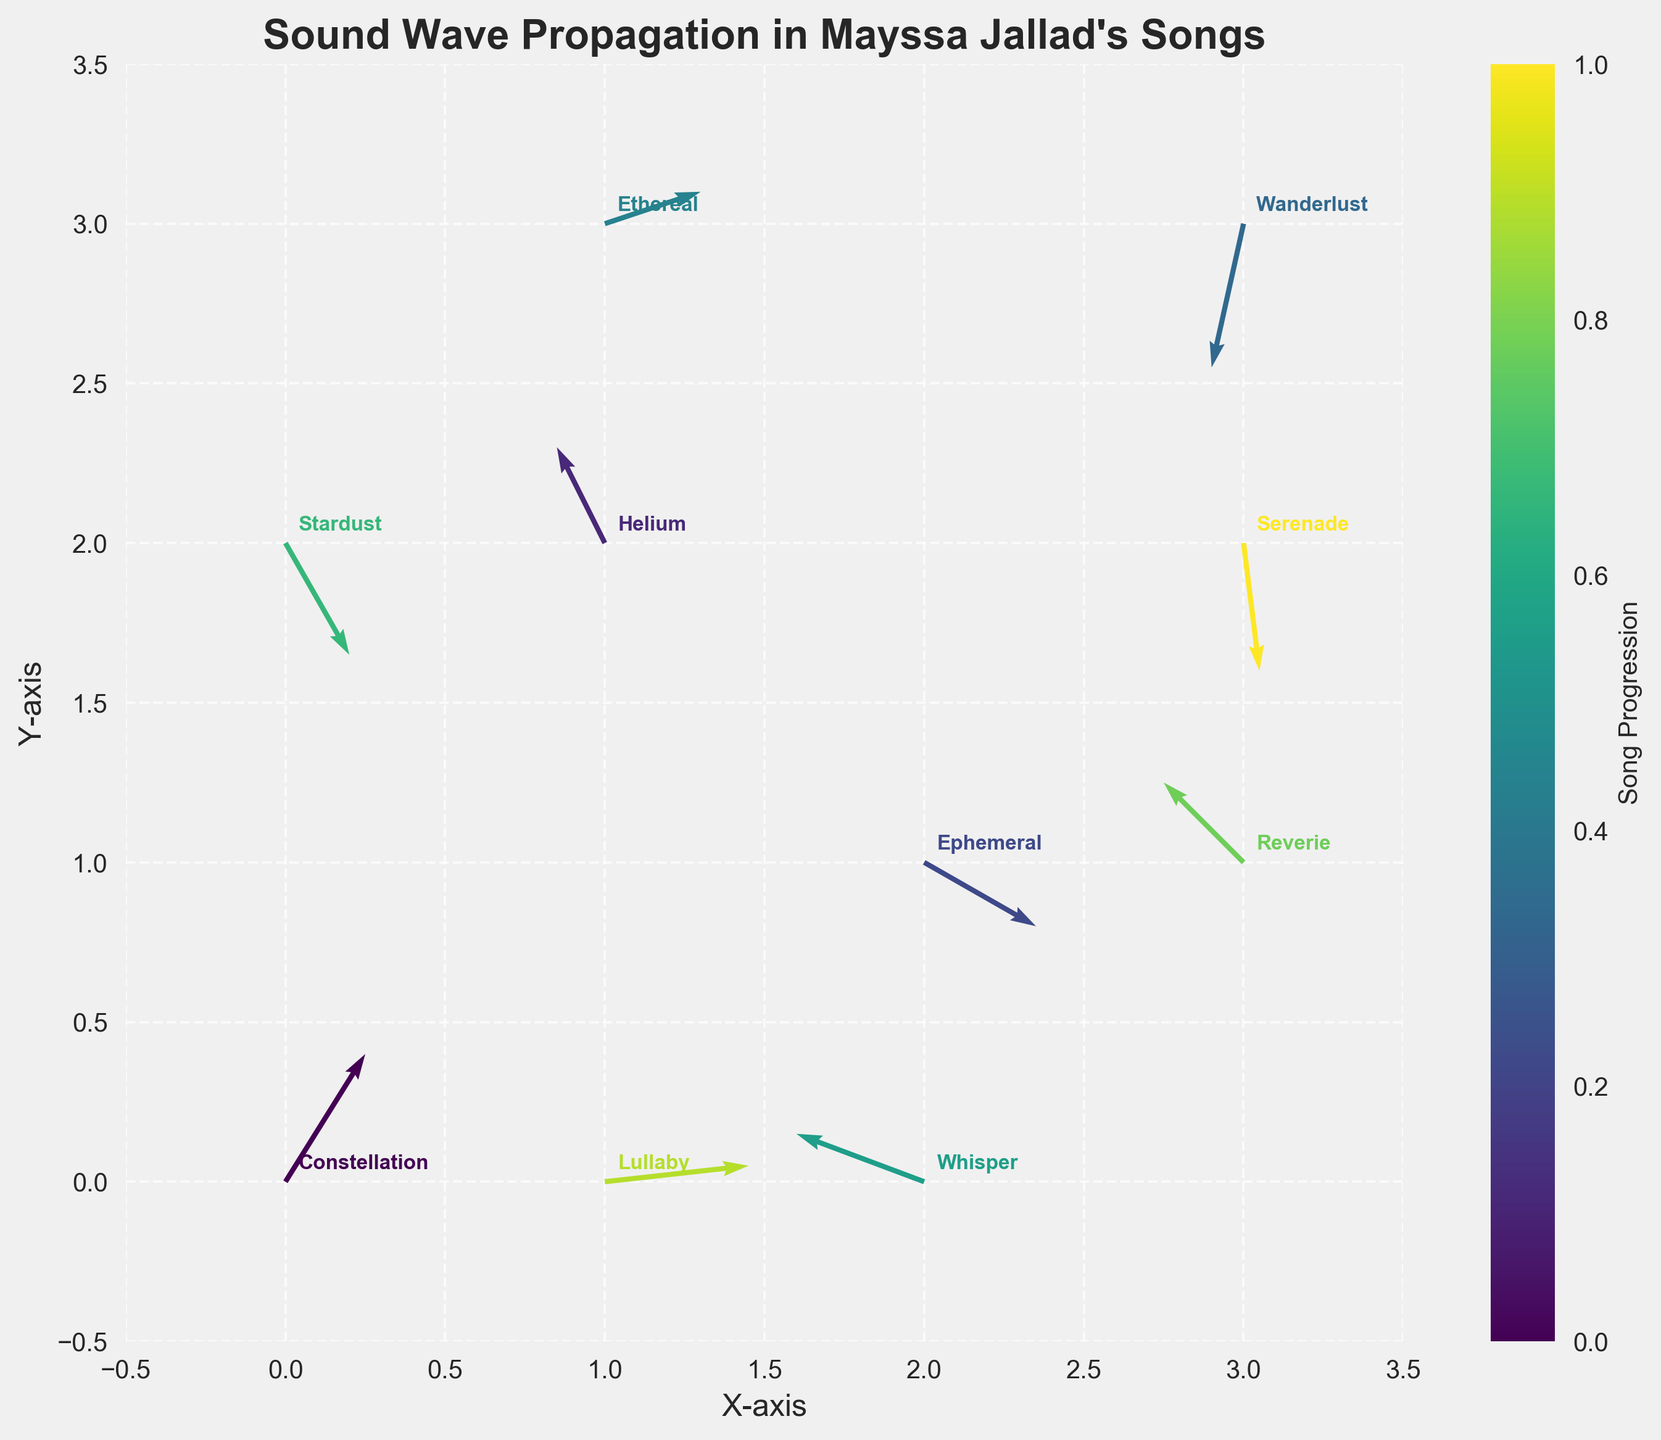What is the title of the figure? The title of the figure is typically displayed at the top center part of the plot. In this case, it reads "Sound Wave Propagation in Mayssa Jallad's Songs".
Answer: Sound Wave Propagation in Mayssa Jallad's Songs How many songs are represented in the figure? The figure has one quiver arrow and one annotation for each unique song. By counting the annotations or arrows, we find that there are 10 songs represented.
Answer: 10 Which song corresponds to the quiver located at coordinate (3, 2)? The song annotations near the coordinates can help us identify it. The annotation closest to (3, 2) is "Serenade".
Answer: Serenade What is the direction of the quiver associated with the song "Lullaby"? The quiver corresponding to "Lullaby" starts from coordinate (1, 0) and has direction components u=0.9 and v=0.1. This means it points roughly to the right and slightly upwards.
Answer: Right and slightly upwards Which song has the largest magnitude vector? To find this, look for the highest value in the magnitude data. The song with the largest magnitude (0.94) is "Constellation".
Answer: Constellation What is the general trend of the quiver vectors' directions? By observing the orientations of the quiver arrows, many vectors seem to have positive or negative values of both x and y components, showing diversity and complexity in directions.
Answer: Diverse directions with no singular trend What is the average magnitude of the vectors in the plot? The magnitudes listed are 0.94, 0.67, 0.81, 0.92, 0.63, 0.85, 0.81, 0.71, 0.91, and 0.81. Summing these gives 7.06, and dividing by the number of songs (10) gives us 0.706.
Answer: 0.706 Which song’s quiver has the largest positive x-component (u)? The song with the largest positive x-component (u) can be identified by checking individual u values. "Lullaby" has u=0.9, which is the highest.
Answer: Lullaby Which two songs’ quivers point in almost completely opposite directions? By comparing the directions of the u and v components, we can infer that "Constellation" (u=0.5, v=0.8) and "Wanderlust" (u=-0.2, v=-0.9) point in nearly opposite directions.
Answer: Constellation and Wanderlust Which song has quiver vectors closest to the origin with a downward direction? Quivers closest to the origin that point downward would have negative y-components. Observing this, "Ephemeral" at (2,1) has u=0.7 and v=-0.4.
Answer: Ephemeral 